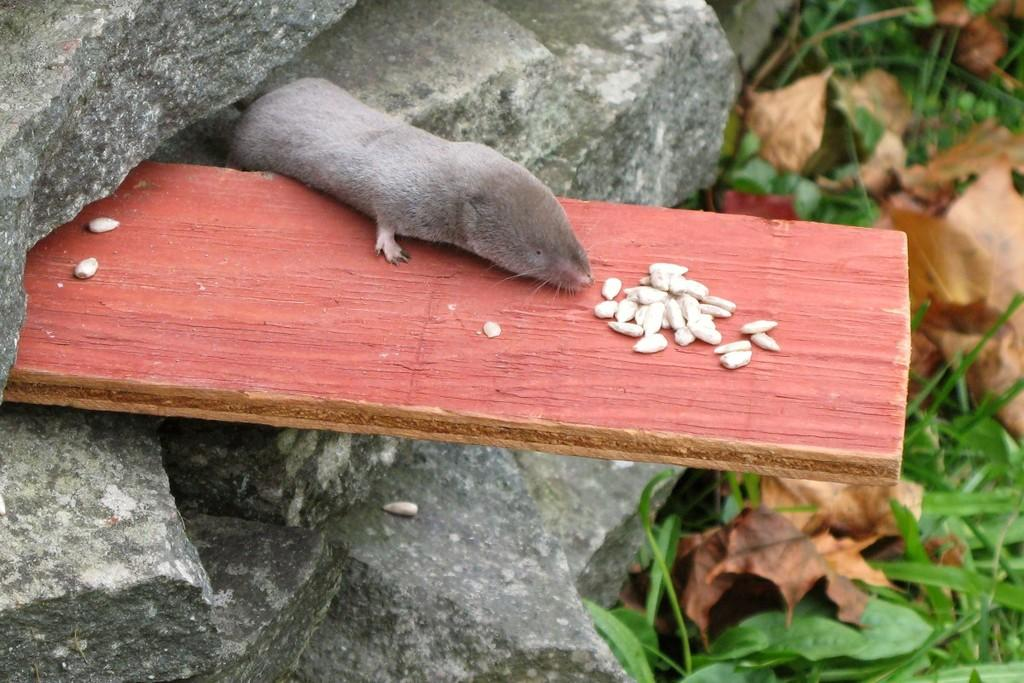What is the main object in the image? There is a wooden plank in the image. Where is the wooden plank located? The wooden plank is between rocks. What animal can be seen on the wooden plank? There is a rat on the wooden plank. What is the rat doing in the image? The rat is eating something. What type of vegetation is present in the image? There are leaves in the image. What rhythm is the wooden plank playing in the image? The wooden plank is not playing any rhythm in the image; it is a stationary object. 